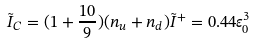Convert formula to latex. <formula><loc_0><loc_0><loc_500><loc_500>\tilde { I } _ { C } = ( 1 + \frac { 1 0 } { 9 } ) ( n _ { u } + n _ { d } ) \tilde { I } ^ { + } = 0 . 4 4 \varepsilon ^ { 3 } _ { 0 }</formula> 